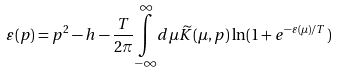Convert formula to latex. <formula><loc_0><loc_0><loc_500><loc_500>\varepsilon ( p ) = p ^ { 2 } - h - \frac { T } { 2 \pi } \underset { - \infty } { \overset { \infty } { \int } } d \mu \widetilde { K } ( \mu , p ) \ln ( 1 + e ^ { - \varepsilon ( \mu ) / T } )</formula> 